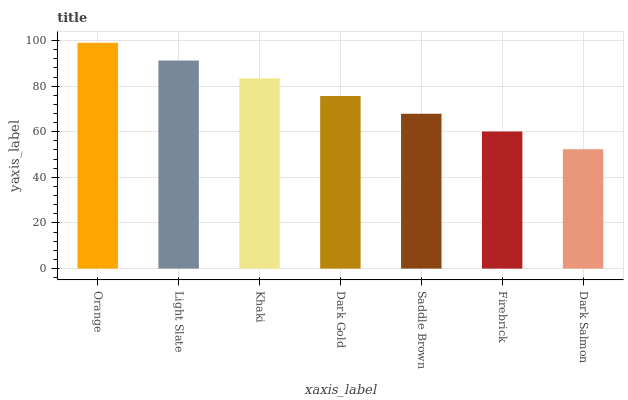Is Dark Salmon the minimum?
Answer yes or no. Yes. Is Orange the maximum?
Answer yes or no. Yes. Is Light Slate the minimum?
Answer yes or no. No. Is Light Slate the maximum?
Answer yes or no. No. Is Orange greater than Light Slate?
Answer yes or no. Yes. Is Light Slate less than Orange?
Answer yes or no. Yes. Is Light Slate greater than Orange?
Answer yes or no. No. Is Orange less than Light Slate?
Answer yes or no. No. Is Dark Gold the high median?
Answer yes or no. Yes. Is Dark Gold the low median?
Answer yes or no. Yes. Is Dark Salmon the high median?
Answer yes or no. No. Is Light Slate the low median?
Answer yes or no. No. 